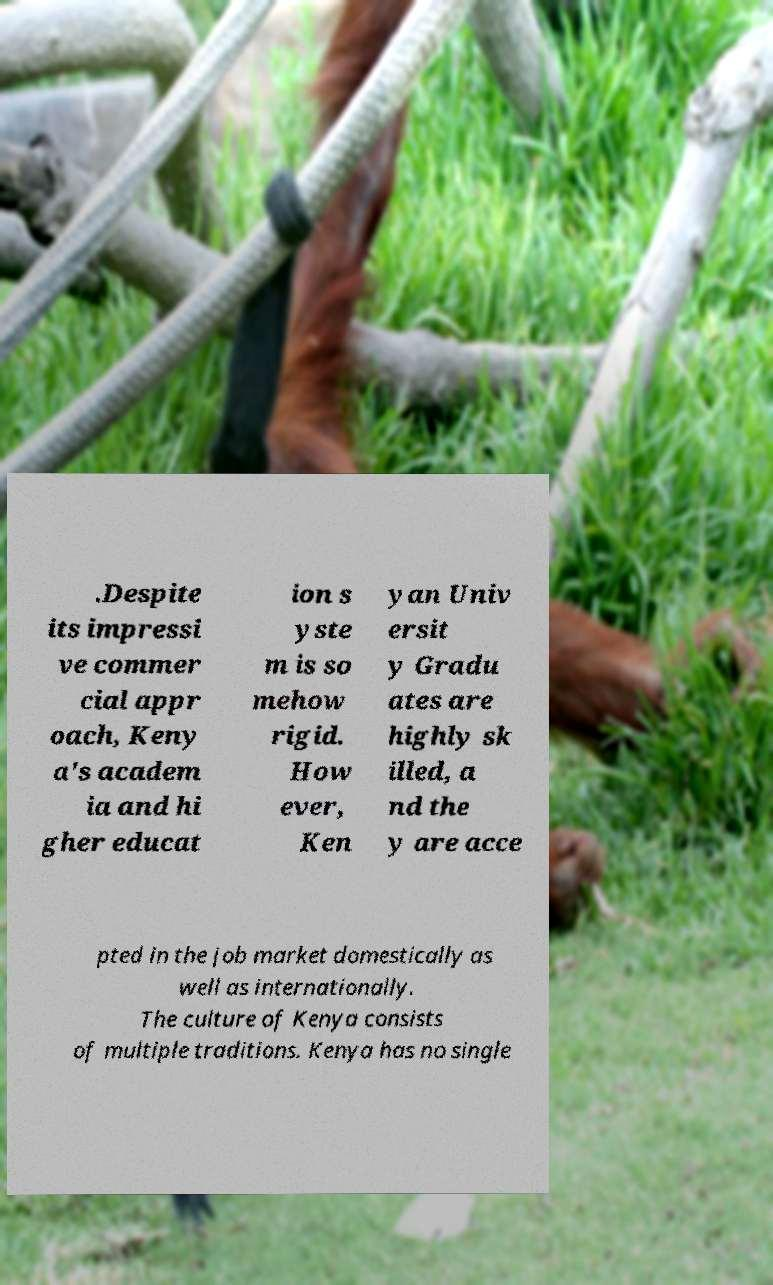What messages or text are displayed in this image? I need them in a readable, typed format. .Despite its impressi ve commer cial appr oach, Keny a's academ ia and hi gher educat ion s yste m is so mehow rigid. How ever, Ken yan Univ ersit y Gradu ates are highly sk illed, a nd the y are acce pted in the job market domestically as well as internationally. The culture of Kenya consists of multiple traditions. Kenya has no single 